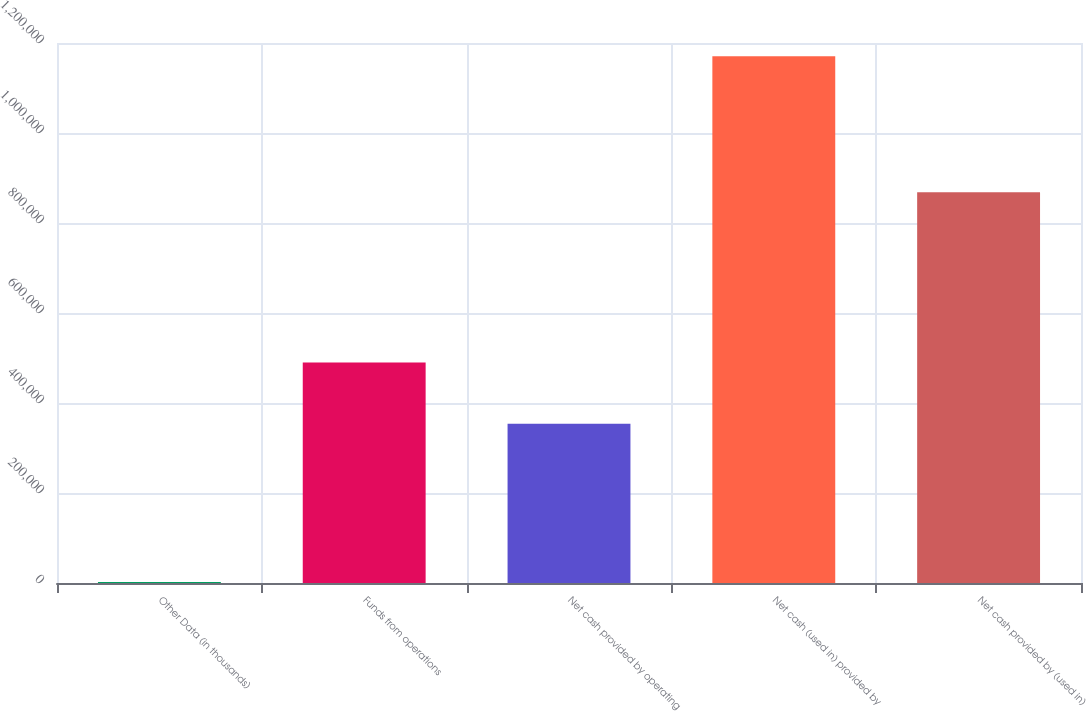Convert chart to OTSL. <chart><loc_0><loc_0><loc_500><loc_500><bar_chart><fcel>Other Data (in thousands)<fcel>Funds from operations<fcel>Net cash provided by operating<fcel>Net cash (used in) provided by<fcel>Net cash provided by (used in)<nl><fcel>2012<fcel>490255<fcel>353743<fcel>1.17039e+06<fcel>868442<nl></chart> 